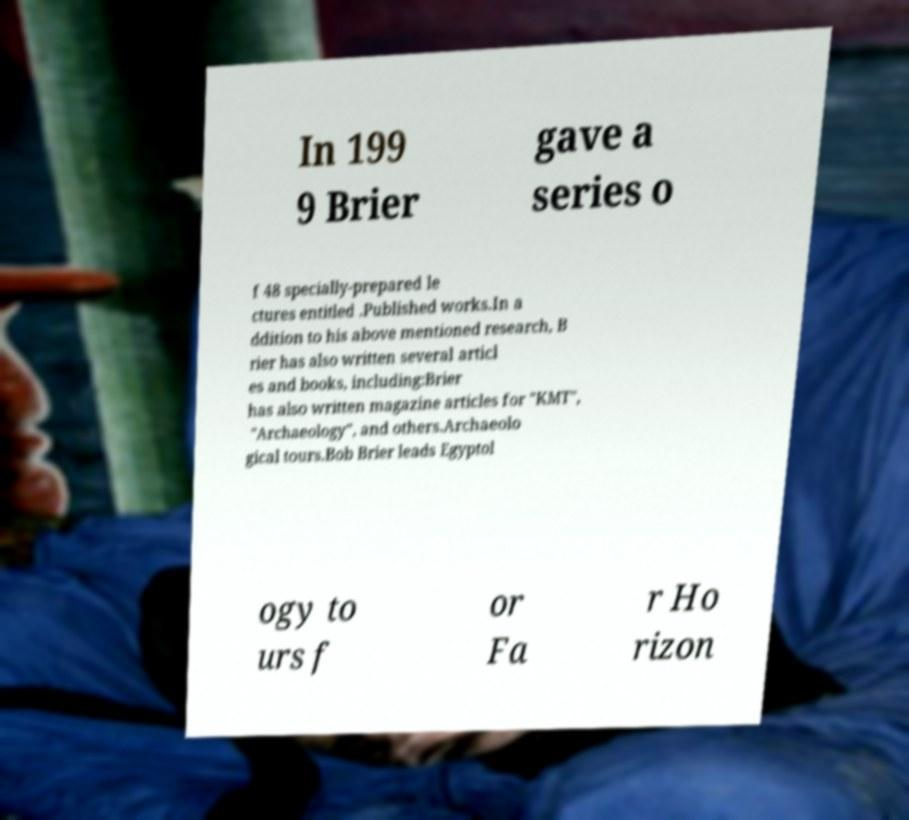Could you assist in decoding the text presented in this image and type it out clearly? In 199 9 Brier gave a series o f 48 specially-prepared le ctures entitled .Published works.In a ddition to his above mentioned research, B rier has also written several articl es and books, including:Brier has also written magazine articles for "KMT", "Archaeology", and others.Archaeolo gical tours.Bob Brier leads Egyptol ogy to urs f or Fa r Ho rizon 